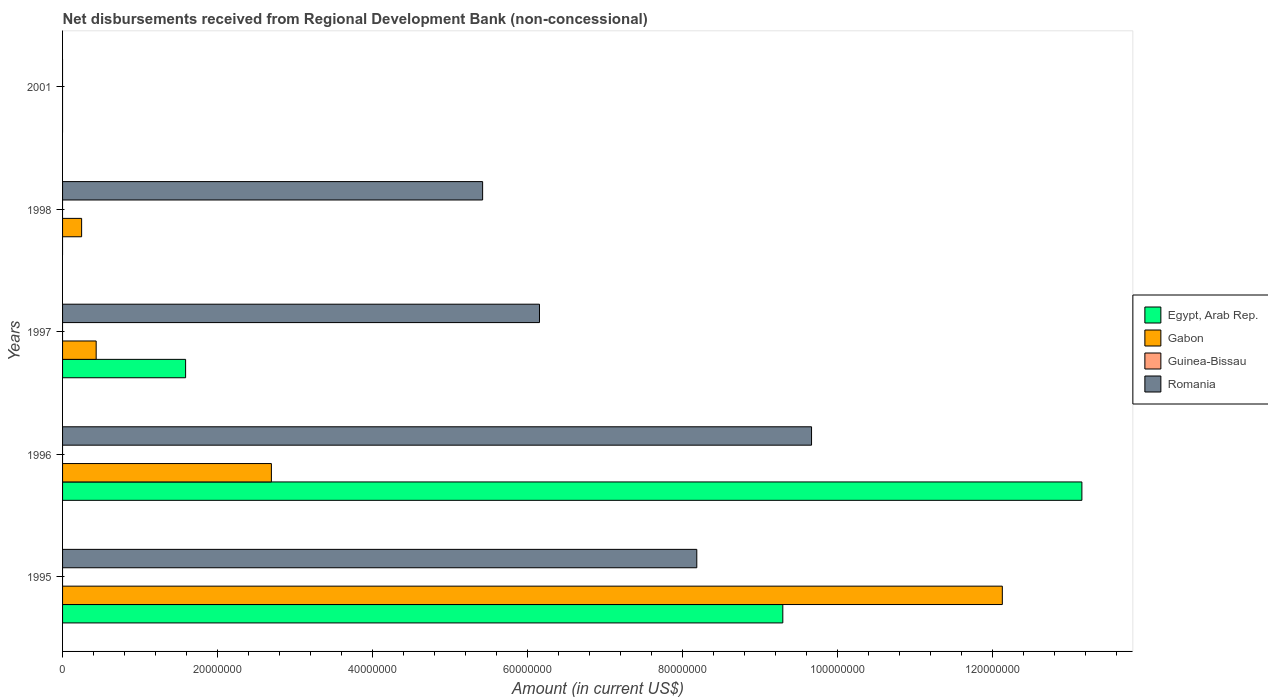Are the number of bars per tick equal to the number of legend labels?
Provide a short and direct response. No. Are the number of bars on each tick of the Y-axis equal?
Ensure brevity in your answer.  No. How many bars are there on the 5th tick from the top?
Provide a short and direct response. 3. How many bars are there on the 3rd tick from the bottom?
Your answer should be very brief. 3. What is the label of the 2nd group of bars from the top?
Offer a terse response. 1998. What is the amount of disbursements received from Regional Development Bank in Gabon in 1997?
Your answer should be very brief. 4.34e+06. Across all years, what is the maximum amount of disbursements received from Regional Development Bank in Egypt, Arab Rep.?
Your answer should be compact. 1.31e+08. In which year was the amount of disbursements received from Regional Development Bank in Gabon maximum?
Offer a very short reply. 1995. What is the total amount of disbursements received from Regional Development Bank in Romania in the graph?
Offer a terse response. 2.94e+08. What is the difference between the amount of disbursements received from Regional Development Bank in Egypt, Arab Rep. in 1996 and that in 1997?
Your answer should be compact. 1.16e+08. What is the difference between the amount of disbursements received from Regional Development Bank in Gabon in 1996 and the amount of disbursements received from Regional Development Bank in Guinea-Bissau in 1995?
Your answer should be compact. 2.69e+07. What is the average amount of disbursements received from Regional Development Bank in Gabon per year?
Your answer should be very brief. 3.10e+07. In the year 1996, what is the difference between the amount of disbursements received from Regional Development Bank in Gabon and amount of disbursements received from Regional Development Bank in Romania?
Your response must be concise. -6.97e+07. Is the difference between the amount of disbursements received from Regional Development Bank in Gabon in 1996 and 1997 greater than the difference between the amount of disbursements received from Regional Development Bank in Romania in 1996 and 1997?
Offer a very short reply. No. What is the difference between the highest and the second highest amount of disbursements received from Regional Development Bank in Romania?
Provide a succinct answer. 1.48e+07. What is the difference between the highest and the lowest amount of disbursements received from Regional Development Bank in Egypt, Arab Rep.?
Your response must be concise. 1.31e+08. Is it the case that in every year, the sum of the amount of disbursements received from Regional Development Bank in Romania and amount of disbursements received from Regional Development Bank in Gabon is greater than the amount of disbursements received from Regional Development Bank in Guinea-Bissau?
Offer a terse response. No. How many years are there in the graph?
Make the answer very short. 5. Are the values on the major ticks of X-axis written in scientific E-notation?
Make the answer very short. No. Does the graph contain any zero values?
Make the answer very short. Yes. Does the graph contain grids?
Provide a short and direct response. No. How many legend labels are there?
Make the answer very short. 4. How are the legend labels stacked?
Keep it short and to the point. Vertical. What is the title of the graph?
Offer a terse response. Net disbursements received from Regional Development Bank (non-concessional). What is the label or title of the Y-axis?
Ensure brevity in your answer.  Years. What is the Amount (in current US$) of Egypt, Arab Rep. in 1995?
Give a very brief answer. 9.29e+07. What is the Amount (in current US$) in Gabon in 1995?
Provide a short and direct response. 1.21e+08. What is the Amount (in current US$) in Guinea-Bissau in 1995?
Your response must be concise. 0. What is the Amount (in current US$) of Romania in 1995?
Offer a terse response. 8.18e+07. What is the Amount (in current US$) of Egypt, Arab Rep. in 1996?
Your answer should be very brief. 1.31e+08. What is the Amount (in current US$) in Gabon in 1996?
Offer a very short reply. 2.69e+07. What is the Amount (in current US$) in Romania in 1996?
Provide a succinct answer. 9.66e+07. What is the Amount (in current US$) in Egypt, Arab Rep. in 1997?
Provide a succinct answer. 1.59e+07. What is the Amount (in current US$) of Gabon in 1997?
Provide a short and direct response. 4.34e+06. What is the Amount (in current US$) in Guinea-Bissau in 1997?
Offer a very short reply. 0. What is the Amount (in current US$) in Romania in 1997?
Your response must be concise. 6.15e+07. What is the Amount (in current US$) of Gabon in 1998?
Provide a short and direct response. 2.46e+06. What is the Amount (in current US$) of Romania in 1998?
Ensure brevity in your answer.  5.42e+07. What is the Amount (in current US$) in Egypt, Arab Rep. in 2001?
Offer a terse response. 0. What is the Amount (in current US$) of Guinea-Bissau in 2001?
Offer a terse response. 0. Across all years, what is the maximum Amount (in current US$) of Egypt, Arab Rep.?
Your answer should be very brief. 1.31e+08. Across all years, what is the maximum Amount (in current US$) in Gabon?
Your answer should be very brief. 1.21e+08. Across all years, what is the maximum Amount (in current US$) in Romania?
Your answer should be compact. 9.66e+07. Across all years, what is the minimum Amount (in current US$) of Egypt, Arab Rep.?
Make the answer very short. 0. Across all years, what is the minimum Amount (in current US$) of Romania?
Offer a terse response. 0. What is the total Amount (in current US$) of Egypt, Arab Rep. in the graph?
Your answer should be very brief. 2.40e+08. What is the total Amount (in current US$) of Gabon in the graph?
Give a very brief answer. 1.55e+08. What is the total Amount (in current US$) of Romania in the graph?
Your answer should be compact. 2.94e+08. What is the difference between the Amount (in current US$) in Egypt, Arab Rep. in 1995 and that in 1996?
Ensure brevity in your answer.  -3.86e+07. What is the difference between the Amount (in current US$) in Gabon in 1995 and that in 1996?
Your answer should be compact. 9.43e+07. What is the difference between the Amount (in current US$) in Romania in 1995 and that in 1996?
Provide a succinct answer. -1.48e+07. What is the difference between the Amount (in current US$) in Egypt, Arab Rep. in 1995 and that in 1997?
Make the answer very short. 7.70e+07. What is the difference between the Amount (in current US$) of Gabon in 1995 and that in 1997?
Offer a very short reply. 1.17e+08. What is the difference between the Amount (in current US$) in Romania in 1995 and that in 1997?
Ensure brevity in your answer.  2.03e+07. What is the difference between the Amount (in current US$) in Gabon in 1995 and that in 1998?
Provide a short and direct response. 1.19e+08. What is the difference between the Amount (in current US$) of Romania in 1995 and that in 1998?
Your response must be concise. 2.76e+07. What is the difference between the Amount (in current US$) in Egypt, Arab Rep. in 1996 and that in 1997?
Keep it short and to the point. 1.16e+08. What is the difference between the Amount (in current US$) in Gabon in 1996 and that in 1997?
Keep it short and to the point. 2.26e+07. What is the difference between the Amount (in current US$) of Romania in 1996 and that in 1997?
Your answer should be very brief. 3.51e+07. What is the difference between the Amount (in current US$) of Gabon in 1996 and that in 1998?
Offer a terse response. 2.45e+07. What is the difference between the Amount (in current US$) in Romania in 1996 and that in 1998?
Give a very brief answer. 4.24e+07. What is the difference between the Amount (in current US$) in Gabon in 1997 and that in 1998?
Your response must be concise. 1.88e+06. What is the difference between the Amount (in current US$) of Romania in 1997 and that in 1998?
Your answer should be compact. 7.33e+06. What is the difference between the Amount (in current US$) in Egypt, Arab Rep. in 1995 and the Amount (in current US$) in Gabon in 1996?
Provide a succinct answer. 6.60e+07. What is the difference between the Amount (in current US$) in Egypt, Arab Rep. in 1995 and the Amount (in current US$) in Romania in 1996?
Make the answer very short. -3.71e+06. What is the difference between the Amount (in current US$) in Gabon in 1995 and the Amount (in current US$) in Romania in 1996?
Ensure brevity in your answer.  2.46e+07. What is the difference between the Amount (in current US$) of Egypt, Arab Rep. in 1995 and the Amount (in current US$) of Gabon in 1997?
Keep it short and to the point. 8.86e+07. What is the difference between the Amount (in current US$) in Egypt, Arab Rep. in 1995 and the Amount (in current US$) in Romania in 1997?
Your response must be concise. 3.14e+07. What is the difference between the Amount (in current US$) in Gabon in 1995 and the Amount (in current US$) in Romania in 1997?
Your response must be concise. 5.97e+07. What is the difference between the Amount (in current US$) of Egypt, Arab Rep. in 1995 and the Amount (in current US$) of Gabon in 1998?
Ensure brevity in your answer.  9.04e+07. What is the difference between the Amount (in current US$) in Egypt, Arab Rep. in 1995 and the Amount (in current US$) in Romania in 1998?
Make the answer very short. 3.87e+07. What is the difference between the Amount (in current US$) of Gabon in 1995 and the Amount (in current US$) of Romania in 1998?
Your answer should be very brief. 6.70e+07. What is the difference between the Amount (in current US$) in Egypt, Arab Rep. in 1996 and the Amount (in current US$) in Gabon in 1997?
Provide a succinct answer. 1.27e+08. What is the difference between the Amount (in current US$) of Egypt, Arab Rep. in 1996 and the Amount (in current US$) of Romania in 1997?
Offer a terse response. 7.00e+07. What is the difference between the Amount (in current US$) of Gabon in 1996 and the Amount (in current US$) of Romania in 1997?
Give a very brief answer. -3.46e+07. What is the difference between the Amount (in current US$) of Egypt, Arab Rep. in 1996 and the Amount (in current US$) of Gabon in 1998?
Provide a succinct answer. 1.29e+08. What is the difference between the Amount (in current US$) in Egypt, Arab Rep. in 1996 and the Amount (in current US$) in Romania in 1998?
Offer a terse response. 7.73e+07. What is the difference between the Amount (in current US$) in Gabon in 1996 and the Amount (in current US$) in Romania in 1998?
Provide a short and direct response. -2.72e+07. What is the difference between the Amount (in current US$) of Egypt, Arab Rep. in 1997 and the Amount (in current US$) of Gabon in 1998?
Ensure brevity in your answer.  1.34e+07. What is the difference between the Amount (in current US$) in Egypt, Arab Rep. in 1997 and the Amount (in current US$) in Romania in 1998?
Your answer should be very brief. -3.83e+07. What is the difference between the Amount (in current US$) in Gabon in 1997 and the Amount (in current US$) in Romania in 1998?
Provide a succinct answer. -4.98e+07. What is the average Amount (in current US$) in Egypt, Arab Rep. per year?
Offer a very short reply. 4.81e+07. What is the average Amount (in current US$) of Gabon per year?
Give a very brief answer. 3.10e+07. What is the average Amount (in current US$) of Romania per year?
Your response must be concise. 5.88e+07. In the year 1995, what is the difference between the Amount (in current US$) in Egypt, Arab Rep. and Amount (in current US$) in Gabon?
Make the answer very short. -2.83e+07. In the year 1995, what is the difference between the Amount (in current US$) in Egypt, Arab Rep. and Amount (in current US$) in Romania?
Ensure brevity in your answer.  1.11e+07. In the year 1995, what is the difference between the Amount (in current US$) of Gabon and Amount (in current US$) of Romania?
Keep it short and to the point. 3.94e+07. In the year 1996, what is the difference between the Amount (in current US$) in Egypt, Arab Rep. and Amount (in current US$) in Gabon?
Make the answer very short. 1.05e+08. In the year 1996, what is the difference between the Amount (in current US$) in Egypt, Arab Rep. and Amount (in current US$) in Romania?
Give a very brief answer. 3.49e+07. In the year 1996, what is the difference between the Amount (in current US$) in Gabon and Amount (in current US$) in Romania?
Ensure brevity in your answer.  -6.97e+07. In the year 1997, what is the difference between the Amount (in current US$) of Egypt, Arab Rep. and Amount (in current US$) of Gabon?
Ensure brevity in your answer.  1.15e+07. In the year 1997, what is the difference between the Amount (in current US$) of Egypt, Arab Rep. and Amount (in current US$) of Romania?
Ensure brevity in your answer.  -4.56e+07. In the year 1997, what is the difference between the Amount (in current US$) of Gabon and Amount (in current US$) of Romania?
Your answer should be compact. -5.72e+07. In the year 1998, what is the difference between the Amount (in current US$) of Gabon and Amount (in current US$) of Romania?
Provide a succinct answer. -5.17e+07. What is the ratio of the Amount (in current US$) of Egypt, Arab Rep. in 1995 to that in 1996?
Your answer should be compact. 0.71. What is the ratio of the Amount (in current US$) in Gabon in 1995 to that in 1996?
Ensure brevity in your answer.  4.5. What is the ratio of the Amount (in current US$) in Romania in 1995 to that in 1996?
Your answer should be compact. 0.85. What is the ratio of the Amount (in current US$) in Egypt, Arab Rep. in 1995 to that in 1997?
Your answer should be compact. 5.85. What is the ratio of the Amount (in current US$) in Gabon in 1995 to that in 1997?
Keep it short and to the point. 27.96. What is the ratio of the Amount (in current US$) in Romania in 1995 to that in 1997?
Offer a very short reply. 1.33. What is the ratio of the Amount (in current US$) in Gabon in 1995 to that in 1998?
Your response must be concise. 49.32. What is the ratio of the Amount (in current US$) of Romania in 1995 to that in 1998?
Provide a succinct answer. 1.51. What is the ratio of the Amount (in current US$) of Egypt, Arab Rep. in 1996 to that in 1997?
Give a very brief answer. 8.28. What is the ratio of the Amount (in current US$) in Gabon in 1996 to that in 1997?
Provide a succinct answer. 6.21. What is the ratio of the Amount (in current US$) of Romania in 1996 to that in 1997?
Provide a succinct answer. 1.57. What is the ratio of the Amount (in current US$) of Gabon in 1996 to that in 1998?
Keep it short and to the point. 10.96. What is the ratio of the Amount (in current US$) in Romania in 1996 to that in 1998?
Offer a very short reply. 1.78. What is the ratio of the Amount (in current US$) in Gabon in 1997 to that in 1998?
Give a very brief answer. 1.76. What is the ratio of the Amount (in current US$) of Romania in 1997 to that in 1998?
Offer a very short reply. 1.14. What is the difference between the highest and the second highest Amount (in current US$) of Egypt, Arab Rep.?
Your response must be concise. 3.86e+07. What is the difference between the highest and the second highest Amount (in current US$) of Gabon?
Give a very brief answer. 9.43e+07. What is the difference between the highest and the second highest Amount (in current US$) of Romania?
Make the answer very short. 1.48e+07. What is the difference between the highest and the lowest Amount (in current US$) in Egypt, Arab Rep.?
Give a very brief answer. 1.31e+08. What is the difference between the highest and the lowest Amount (in current US$) in Gabon?
Your answer should be very brief. 1.21e+08. What is the difference between the highest and the lowest Amount (in current US$) in Romania?
Provide a succinct answer. 9.66e+07. 